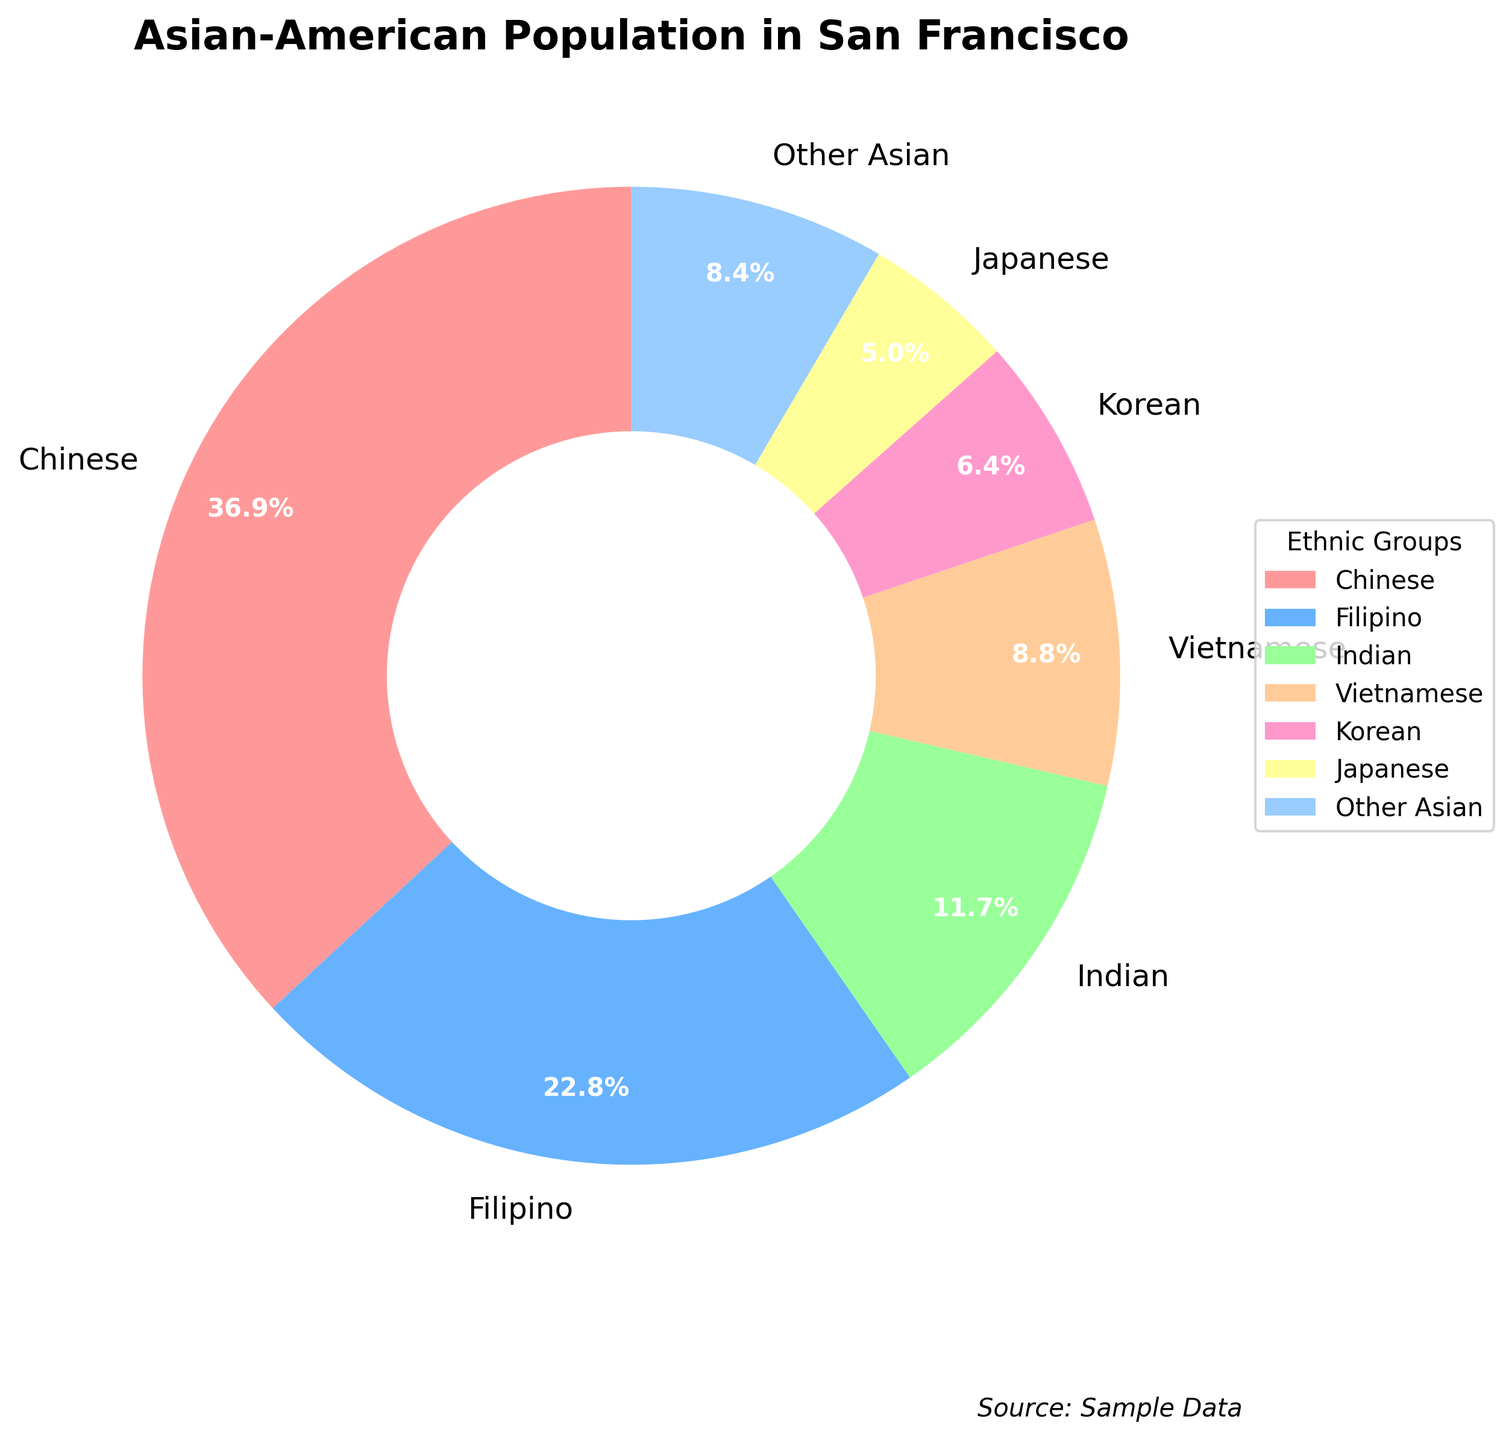Which Asian ethnic group is the largest in San Francisco? The segment representing "Chinese" is the largest in the pie chart.
Answer: Chinese What percentage of the Asian-American population in San Francisco does the Filipino group represent? The segment labeled "Filipino" represents 13.2% of the pie chart.
Answer: 13.2% Compare the percentage of Japanese and Korean populations. Which is larger? The "Japanese" segment represents 2.9%, while the "Korean" segment represents 3.7%. Therefore, the Korean population is larger.
Answer: Korean What is the total percentage of Indian and Vietnamese populations combined? The Indian population is 6.8%, and the Vietnamese population is 5.1%. Adding them together gives 6.8 + 5.1 = 11.9%.
Answer: 11.9% How does the size of the "Other Asian" segment compare to the "Japanese" segment? The "Other Asian" segment is 4.9%, and the "Japanese" segment is 2.9%. The "Other Asian" segment is larger.
Answer: Other Asian What is the ratio of the Chinese population to the Filipino population in San Francisco? The Chinese population is 21.4%, and the Filipino population is 13.2%. The ratio is 21.4:13.2. Simplifying it, we get approximately 1.62:1.
Answer: 1.62:1 How many ethnic groups have population percentages lower than 5%? The groups with percentages lower than 5% are Vietnamese, Korean, Japanese, and Other Asian. These are four groups.
Answer: 4 If you sum the percentages of the populations that have more than 10%, what is the total? The groups with more than 10% are Chinese (21.4%) and Filipino (13.2%). Adding them together gives 21.4 + 13.2 = 34.6%.
Answer: 34.6% If the "Other Asian" segment grew by 1 percentage point, what would its new percentage be? The "Other Asian" segment is currently 4.9%. If it grew by 1 percentage point, it would become 4.9 + 1 = 5.9%.
Answer: 5.9% Considering that the sum of all percentages must be 100%, does the data support this rule? Verify by calculation. Summing all the segments: 21.4 + 13.2 + 6.8 + 5.1 + 3.7 + 2.9 + 4.9 = 58.0%. The remaining percentage might be hidden or part of the graphic design and not visible in the extracted data.
Answer: Data incomplete 